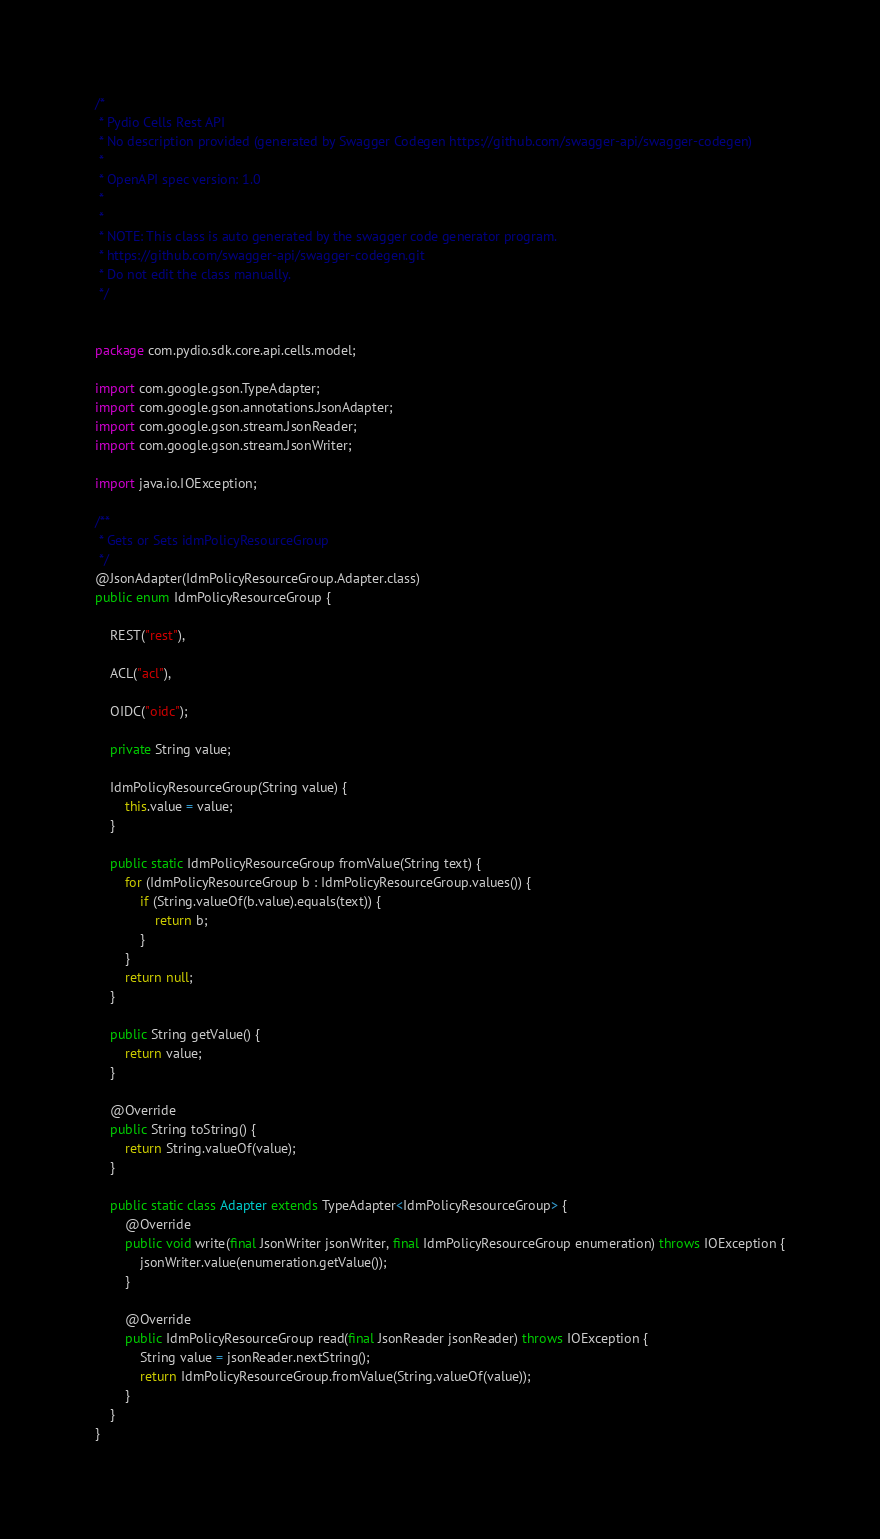Convert code to text. <code><loc_0><loc_0><loc_500><loc_500><_Java_>/*
 * Pydio Cells Rest API
 * No description provided (generated by Swagger Codegen https://github.com/swagger-api/swagger-codegen)
 *
 * OpenAPI spec version: 1.0
 *
 *
 * NOTE: This class is auto generated by the swagger code generator program.
 * https://github.com/swagger-api/swagger-codegen.git
 * Do not edit the class manually.
 */


package com.pydio.sdk.core.api.cells.model;

import com.google.gson.TypeAdapter;
import com.google.gson.annotations.JsonAdapter;
import com.google.gson.stream.JsonReader;
import com.google.gson.stream.JsonWriter;

import java.io.IOException;

/**
 * Gets or Sets idmPolicyResourceGroup
 */
@JsonAdapter(IdmPolicyResourceGroup.Adapter.class)
public enum IdmPolicyResourceGroup {

    REST("rest"),

    ACL("acl"),

    OIDC("oidc");

    private String value;

    IdmPolicyResourceGroup(String value) {
        this.value = value;
    }

    public static IdmPolicyResourceGroup fromValue(String text) {
        for (IdmPolicyResourceGroup b : IdmPolicyResourceGroup.values()) {
            if (String.valueOf(b.value).equals(text)) {
                return b;
            }
        }
        return null;
    }

    public String getValue() {
        return value;
    }

    @Override
    public String toString() {
        return String.valueOf(value);
    }

    public static class Adapter extends TypeAdapter<IdmPolicyResourceGroup> {
        @Override
        public void write(final JsonWriter jsonWriter, final IdmPolicyResourceGroup enumeration) throws IOException {
            jsonWriter.value(enumeration.getValue());
        }

        @Override
        public IdmPolicyResourceGroup read(final JsonReader jsonReader) throws IOException {
            String value = jsonReader.nextString();
            return IdmPolicyResourceGroup.fromValue(String.valueOf(value));
        }
    }
}

</code> 